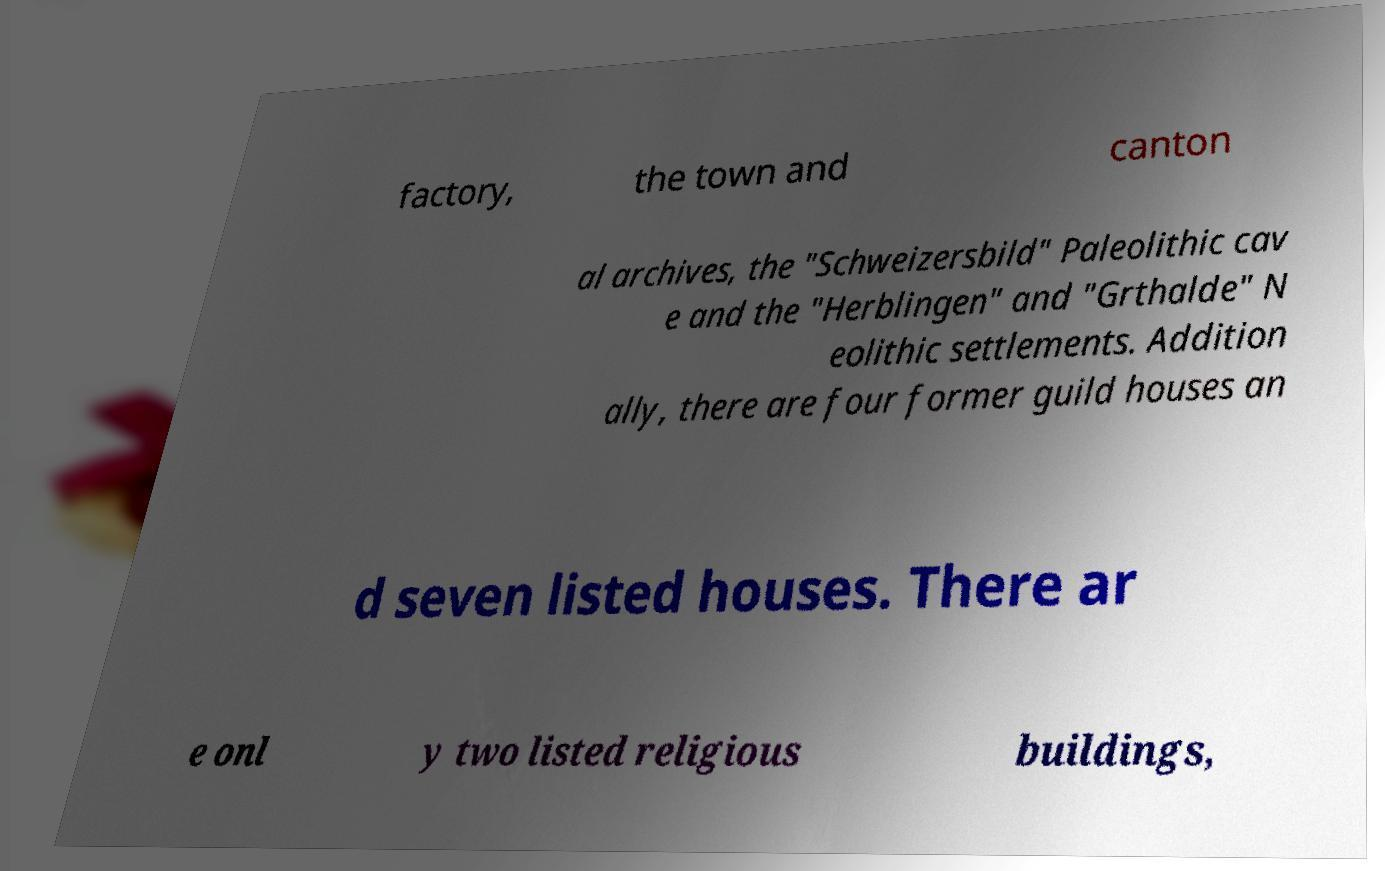I need the written content from this picture converted into text. Can you do that? factory, the town and canton al archives, the "Schweizersbild" Paleolithic cav e and the "Herblingen" and "Grthalde" N eolithic settlements. Addition ally, there are four former guild houses an d seven listed houses. There ar e onl y two listed religious buildings, 